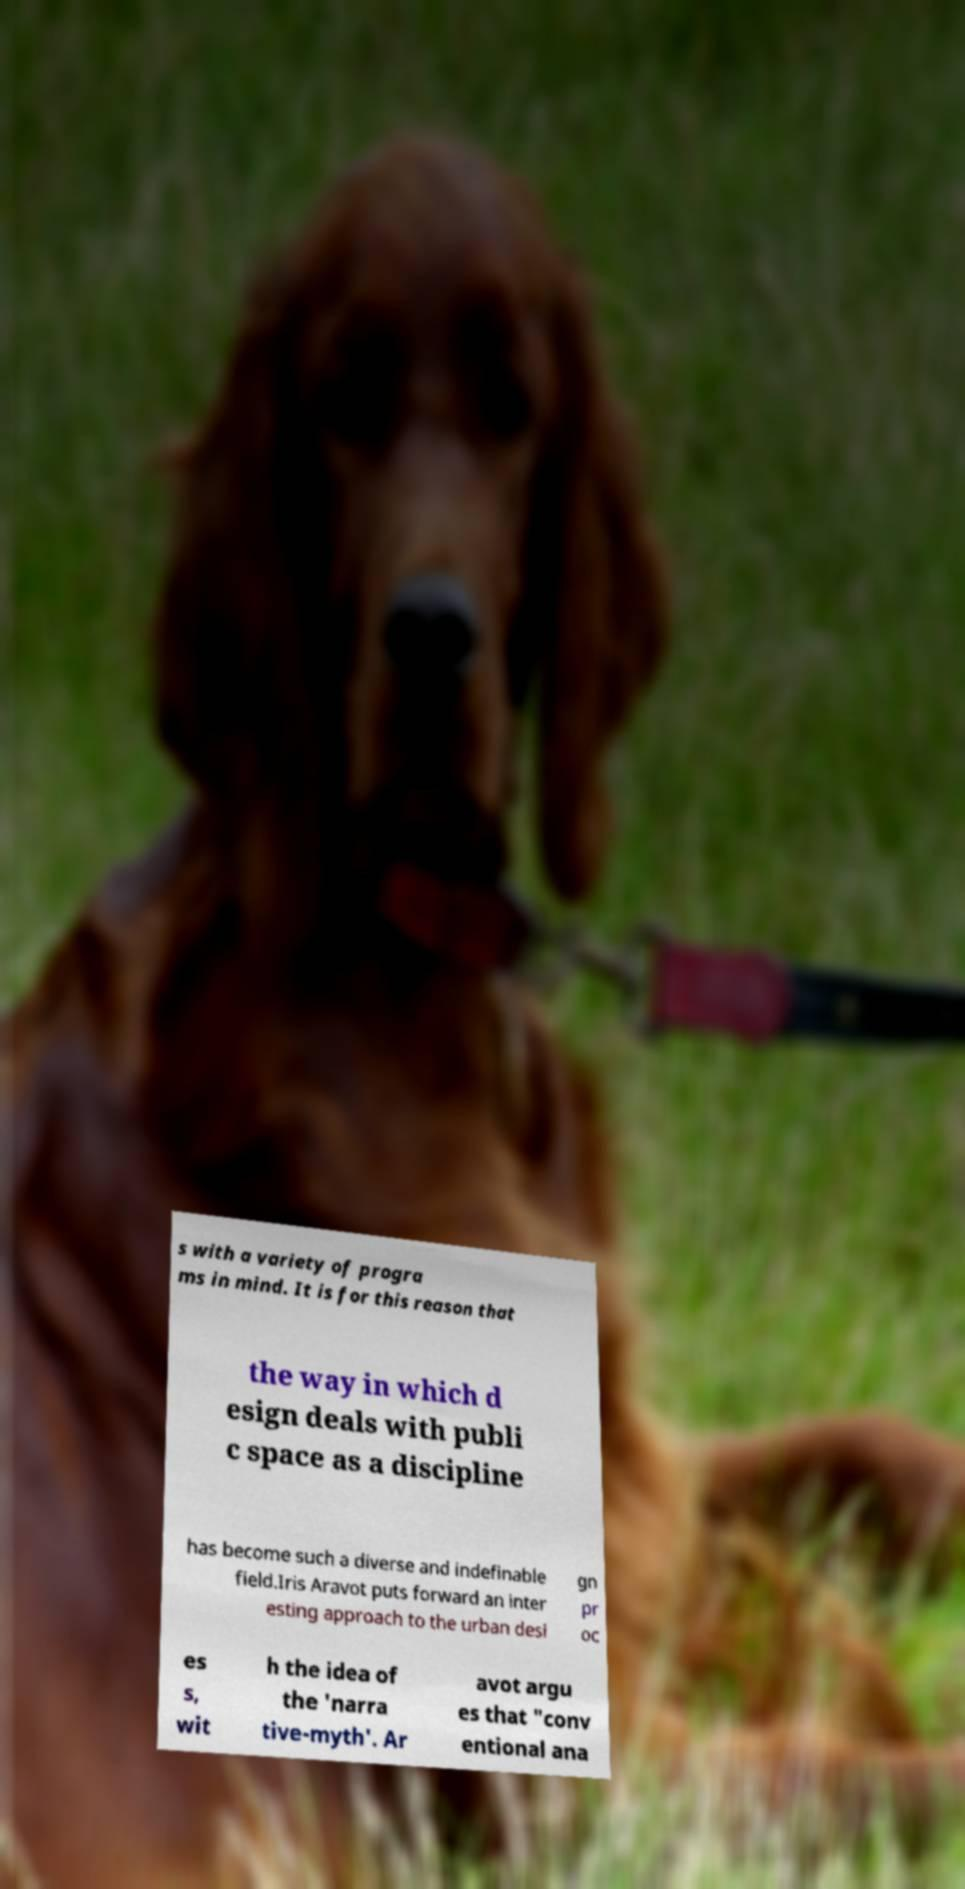I need the written content from this picture converted into text. Can you do that? s with a variety of progra ms in mind. It is for this reason that the way in which d esign deals with publi c space as a discipline has become such a diverse and indefinable field.Iris Aravot puts forward an inter esting approach to the urban desi gn pr oc es s, wit h the idea of the 'narra tive-myth'. Ar avot argu es that "conv entional ana 